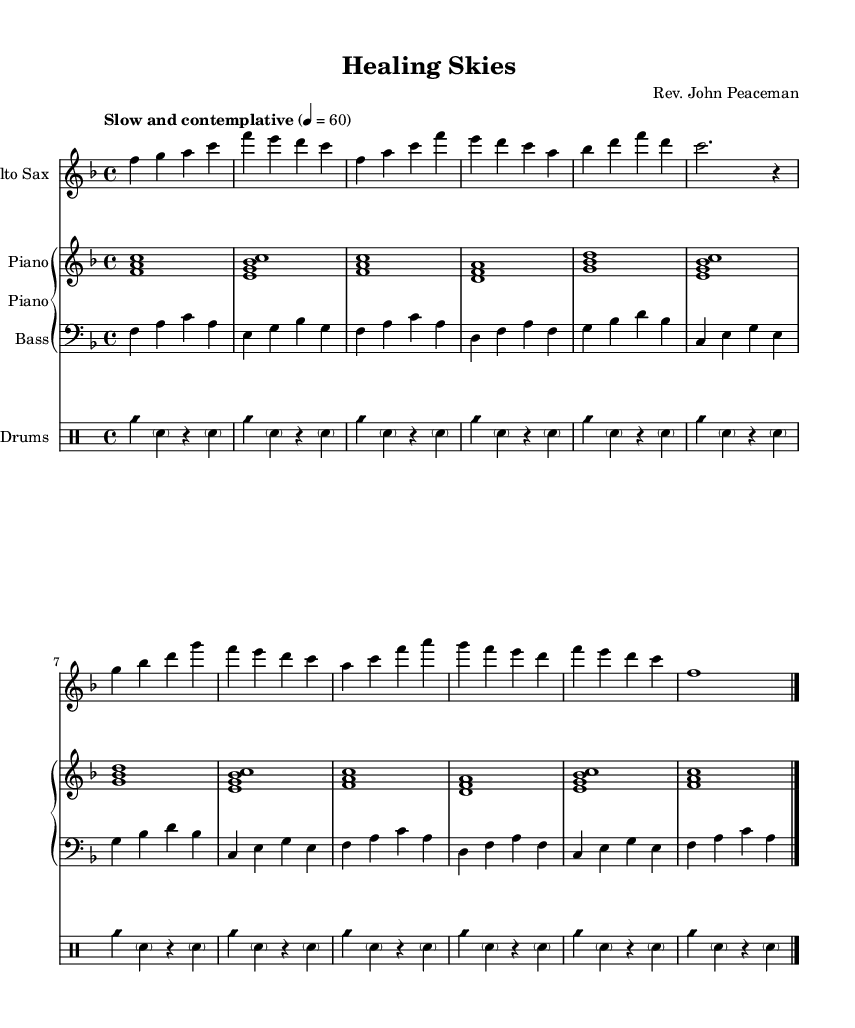What is the key signature of this music? The key signature is F major, which has one flat (B flat). This can be determined by looking at the key signature indicated at the beginning of the piece.
Answer: F major What is the time signature of the piece? The time signature is 4/4, indicated at the start of the music. This means there are four beats in each measure, and each beat is a quarter note.
Answer: 4/4 What tempo marking is given for the piece? The tempo marking is "Slow and contemplative," which describes the feel and speed at which the piece should be played. This is typically placed above the staff at the beginning of the piece.
Answer: Slow and contemplative How many measures are in the A section? The A section contains 8 measures, as seen by counting the measures from the start of the section labeled "A" to its end.
Answer: 8 What instrument is playing the melody in this piece? The melody is played by the Alto Saxophone, which is specified at the beginning of the section for that instrument.
Answer: Alto Saxophone How is the bass line structured throughout the piece? The bass line is structured as a walking bass pattern, characterized by quarter notes that create a steady pulse and outline the harmonic progression. This can be observed in the bass part where it uses step-wise motion and outlines the chords of the piece.
Answer: Walking bass 